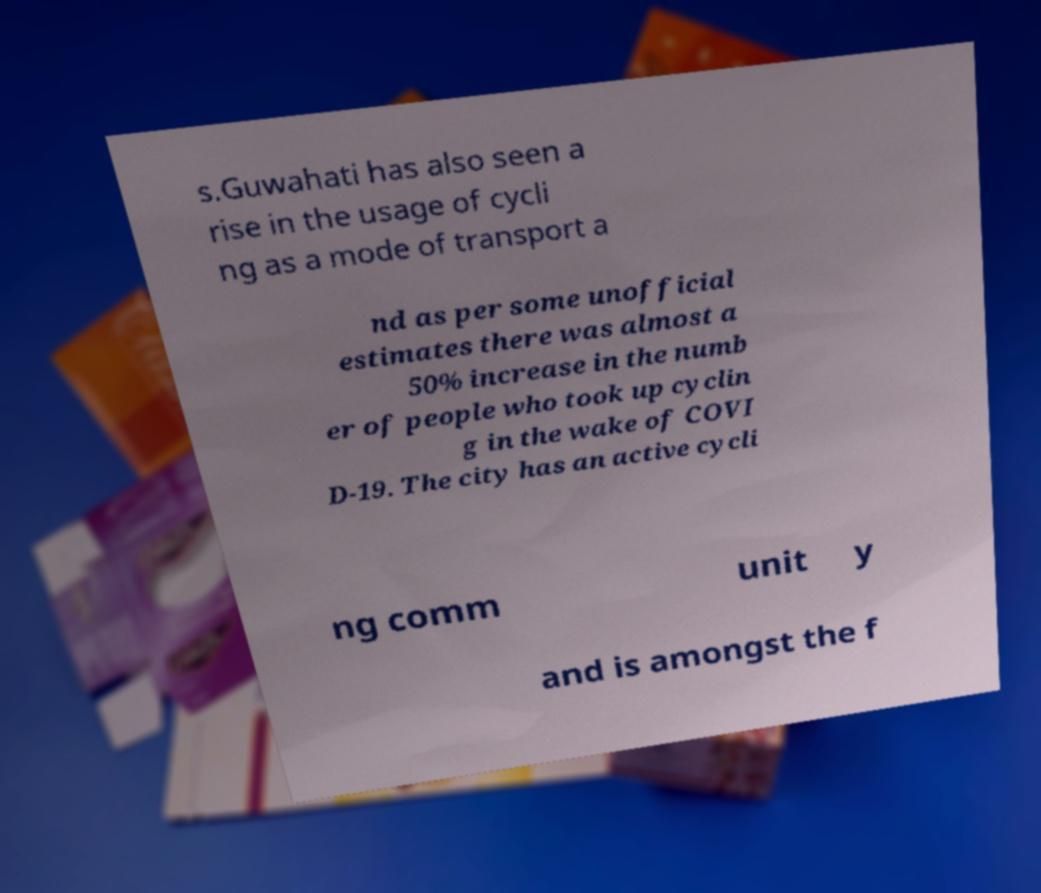Can you accurately transcribe the text from the provided image for me? s.Guwahati has also seen a rise in the usage of cycli ng as a mode of transport a nd as per some unofficial estimates there was almost a 50% increase in the numb er of people who took up cyclin g in the wake of COVI D-19. The city has an active cycli ng comm unit y and is amongst the f 